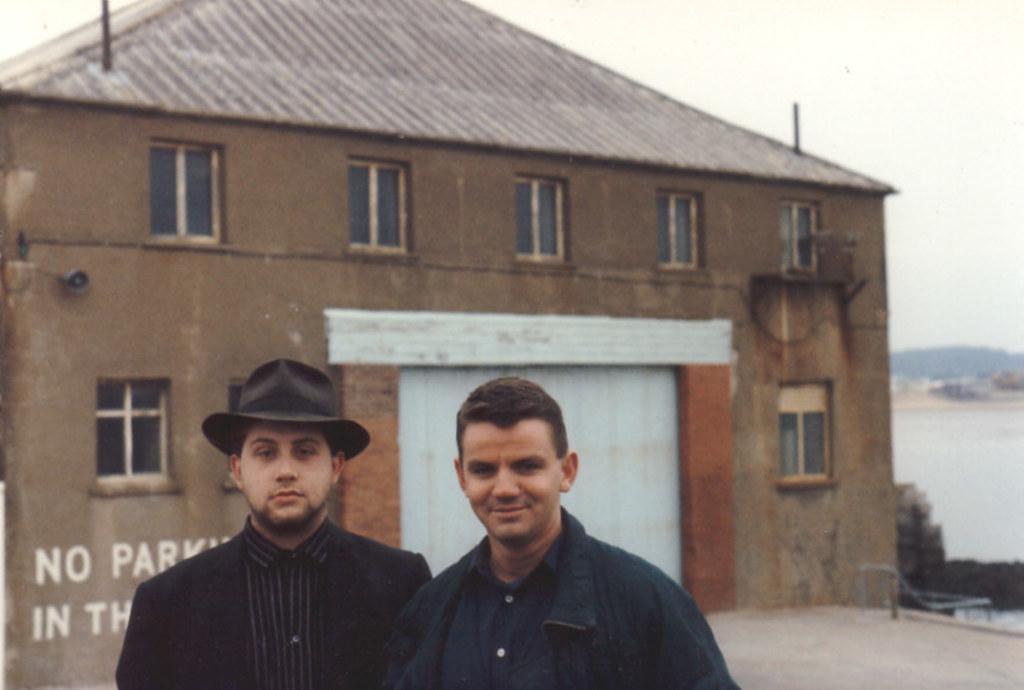In one or two sentences, can you explain what this image depicts? In this image in the foreground ,we can see there are two people standing and on the left side ,one person wearing a cap and at the back there is a house. 